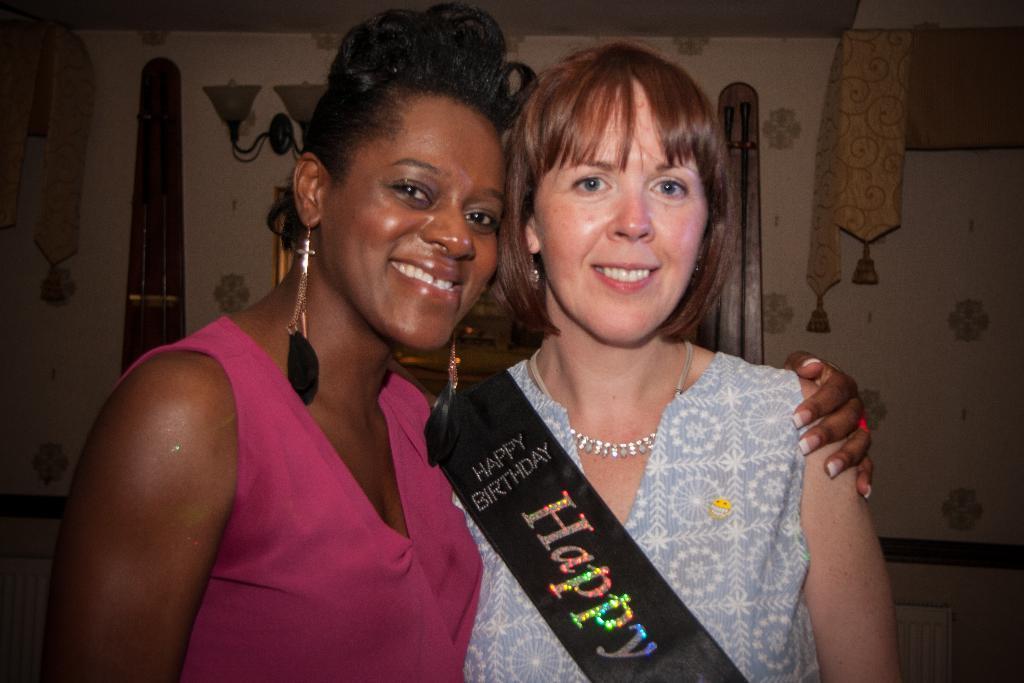Describe this image in one or two sentences. In this image there are two personś smiling, there is the wall behind the persons, there is light behind the persons, there is an object behind the person. 